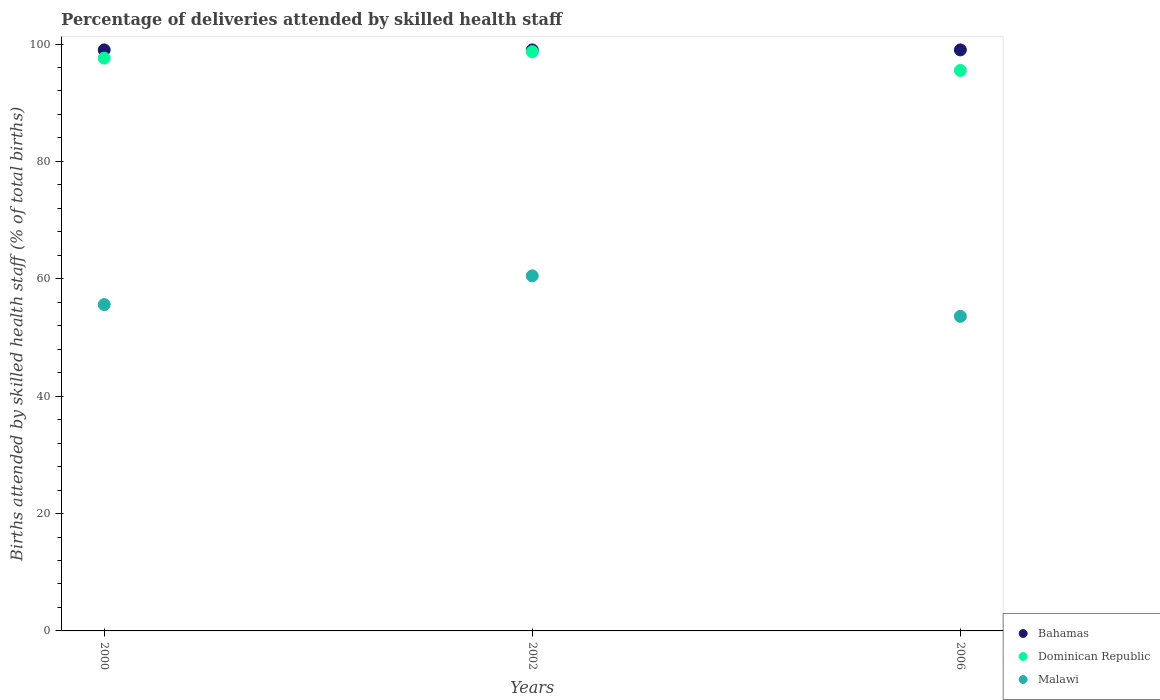Is the number of dotlines equal to the number of legend labels?
Keep it short and to the point. Yes. What is the percentage of births attended by skilled health staff in Dominican Republic in 2002?
Keep it short and to the point. 98.7. Across all years, what is the maximum percentage of births attended by skilled health staff in Bahamas?
Provide a succinct answer. 99. Across all years, what is the minimum percentage of births attended by skilled health staff in Dominican Republic?
Ensure brevity in your answer.  95.5. In which year was the percentage of births attended by skilled health staff in Malawi maximum?
Your response must be concise. 2002. What is the total percentage of births attended by skilled health staff in Malawi in the graph?
Your answer should be compact. 169.7. What is the difference between the percentage of births attended by skilled health staff in Dominican Republic in 2000 and that in 2006?
Make the answer very short. 2.1. What is the difference between the percentage of births attended by skilled health staff in Dominican Republic in 2002 and the percentage of births attended by skilled health staff in Bahamas in 2000?
Offer a very short reply. -0.3. What is the average percentage of births attended by skilled health staff in Dominican Republic per year?
Make the answer very short. 97.27. In the year 2000, what is the difference between the percentage of births attended by skilled health staff in Malawi and percentage of births attended by skilled health staff in Bahamas?
Give a very brief answer. -43.4. Is the difference between the percentage of births attended by skilled health staff in Malawi in 2000 and 2002 greater than the difference between the percentage of births attended by skilled health staff in Bahamas in 2000 and 2002?
Offer a terse response. No. What is the difference between the highest and the second highest percentage of births attended by skilled health staff in Dominican Republic?
Your answer should be compact. 1.1. What is the difference between the highest and the lowest percentage of births attended by skilled health staff in Malawi?
Keep it short and to the point. 6.9. In how many years, is the percentage of births attended by skilled health staff in Bahamas greater than the average percentage of births attended by skilled health staff in Bahamas taken over all years?
Offer a terse response. 0. Is the sum of the percentage of births attended by skilled health staff in Dominican Republic in 2000 and 2002 greater than the maximum percentage of births attended by skilled health staff in Malawi across all years?
Offer a terse response. Yes. Is it the case that in every year, the sum of the percentage of births attended by skilled health staff in Bahamas and percentage of births attended by skilled health staff in Malawi  is greater than the percentage of births attended by skilled health staff in Dominican Republic?
Make the answer very short. Yes. Is the percentage of births attended by skilled health staff in Dominican Republic strictly greater than the percentage of births attended by skilled health staff in Bahamas over the years?
Keep it short and to the point. No. How many years are there in the graph?
Your answer should be compact. 3. What is the difference between two consecutive major ticks on the Y-axis?
Your response must be concise. 20. Does the graph contain any zero values?
Make the answer very short. No. How are the legend labels stacked?
Make the answer very short. Vertical. What is the title of the graph?
Provide a succinct answer. Percentage of deliveries attended by skilled health staff. Does "Uruguay" appear as one of the legend labels in the graph?
Provide a succinct answer. No. What is the label or title of the Y-axis?
Your answer should be compact. Births attended by skilled health staff (% of total births). What is the Births attended by skilled health staff (% of total births) of Bahamas in 2000?
Keep it short and to the point. 99. What is the Births attended by skilled health staff (% of total births) in Dominican Republic in 2000?
Provide a succinct answer. 97.6. What is the Births attended by skilled health staff (% of total births) of Malawi in 2000?
Your answer should be compact. 55.6. What is the Births attended by skilled health staff (% of total births) in Bahamas in 2002?
Your response must be concise. 99. What is the Births attended by skilled health staff (% of total births) of Dominican Republic in 2002?
Provide a succinct answer. 98.7. What is the Births attended by skilled health staff (% of total births) in Malawi in 2002?
Offer a terse response. 60.5. What is the Births attended by skilled health staff (% of total births) in Dominican Republic in 2006?
Ensure brevity in your answer.  95.5. What is the Births attended by skilled health staff (% of total births) of Malawi in 2006?
Give a very brief answer. 53.6. Across all years, what is the maximum Births attended by skilled health staff (% of total births) of Dominican Republic?
Provide a succinct answer. 98.7. Across all years, what is the maximum Births attended by skilled health staff (% of total births) of Malawi?
Provide a short and direct response. 60.5. Across all years, what is the minimum Births attended by skilled health staff (% of total births) of Dominican Republic?
Ensure brevity in your answer.  95.5. Across all years, what is the minimum Births attended by skilled health staff (% of total births) in Malawi?
Offer a terse response. 53.6. What is the total Births attended by skilled health staff (% of total births) of Bahamas in the graph?
Offer a terse response. 297. What is the total Births attended by skilled health staff (% of total births) of Dominican Republic in the graph?
Provide a succinct answer. 291.8. What is the total Births attended by skilled health staff (% of total births) of Malawi in the graph?
Make the answer very short. 169.7. What is the difference between the Births attended by skilled health staff (% of total births) in Bahamas in 2000 and that in 2002?
Ensure brevity in your answer.  0. What is the difference between the Births attended by skilled health staff (% of total births) in Malawi in 2000 and that in 2006?
Provide a succinct answer. 2. What is the difference between the Births attended by skilled health staff (% of total births) in Malawi in 2002 and that in 2006?
Your answer should be very brief. 6.9. What is the difference between the Births attended by skilled health staff (% of total births) in Bahamas in 2000 and the Births attended by skilled health staff (% of total births) in Malawi in 2002?
Offer a terse response. 38.5. What is the difference between the Births attended by skilled health staff (% of total births) in Dominican Republic in 2000 and the Births attended by skilled health staff (% of total births) in Malawi in 2002?
Offer a terse response. 37.1. What is the difference between the Births attended by skilled health staff (% of total births) of Bahamas in 2000 and the Births attended by skilled health staff (% of total births) of Malawi in 2006?
Offer a terse response. 45.4. What is the difference between the Births attended by skilled health staff (% of total births) of Dominican Republic in 2000 and the Births attended by skilled health staff (% of total births) of Malawi in 2006?
Make the answer very short. 44. What is the difference between the Births attended by skilled health staff (% of total births) in Bahamas in 2002 and the Births attended by skilled health staff (% of total births) in Malawi in 2006?
Provide a short and direct response. 45.4. What is the difference between the Births attended by skilled health staff (% of total births) of Dominican Republic in 2002 and the Births attended by skilled health staff (% of total births) of Malawi in 2006?
Make the answer very short. 45.1. What is the average Births attended by skilled health staff (% of total births) of Bahamas per year?
Your answer should be very brief. 99. What is the average Births attended by skilled health staff (% of total births) of Dominican Republic per year?
Your answer should be compact. 97.27. What is the average Births attended by skilled health staff (% of total births) of Malawi per year?
Your answer should be very brief. 56.57. In the year 2000, what is the difference between the Births attended by skilled health staff (% of total births) in Bahamas and Births attended by skilled health staff (% of total births) in Dominican Republic?
Offer a terse response. 1.4. In the year 2000, what is the difference between the Births attended by skilled health staff (% of total births) of Bahamas and Births attended by skilled health staff (% of total births) of Malawi?
Provide a short and direct response. 43.4. In the year 2002, what is the difference between the Births attended by skilled health staff (% of total births) of Bahamas and Births attended by skilled health staff (% of total births) of Malawi?
Offer a terse response. 38.5. In the year 2002, what is the difference between the Births attended by skilled health staff (% of total births) of Dominican Republic and Births attended by skilled health staff (% of total births) of Malawi?
Give a very brief answer. 38.2. In the year 2006, what is the difference between the Births attended by skilled health staff (% of total births) of Bahamas and Births attended by skilled health staff (% of total births) of Dominican Republic?
Keep it short and to the point. 3.5. In the year 2006, what is the difference between the Births attended by skilled health staff (% of total births) in Bahamas and Births attended by skilled health staff (% of total births) in Malawi?
Provide a short and direct response. 45.4. In the year 2006, what is the difference between the Births attended by skilled health staff (% of total births) in Dominican Republic and Births attended by skilled health staff (% of total births) in Malawi?
Provide a short and direct response. 41.9. What is the ratio of the Births attended by skilled health staff (% of total births) of Dominican Republic in 2000 to that in 2002?
Keep it short and to the point. 0.99. What is the ratio of the Births attended by skilled health staff (% of total births) in Malawi in 2000 to that in 2002?
Your answer should be compact. 0.92. What is the ratio of the Births attended by skilled health staff (% of total births) of Dominican Republic in 2000 to that in 2006?
Offer a terse response. 1.02. What is the ratio of the Births attended by skilled health staff (% of total births) of Malawi in 2000 to that in 2006?
Make the answer very short. 1.04. What is the ratio of the Births attended by skilled health staff (% of total births) of Bahamas in 2002 to that in 2006?
Provide a succinct answer. 1. What is the ratio of the Births attended by skilled health staff (% of total births) in Dominican Republic in 2002 to that in 2006?
Offer a very short reply. 1.03. What is the ratio of the Births attended by skilled health staff (% of total births) of Malawi in 2002 to that in 2006?
Give a very brief answer. 1.13. What is the difference between the highest and the lowest Births attended by skilled health staff (% of total births) of Bahamas?
Make the answer very short. 0. 